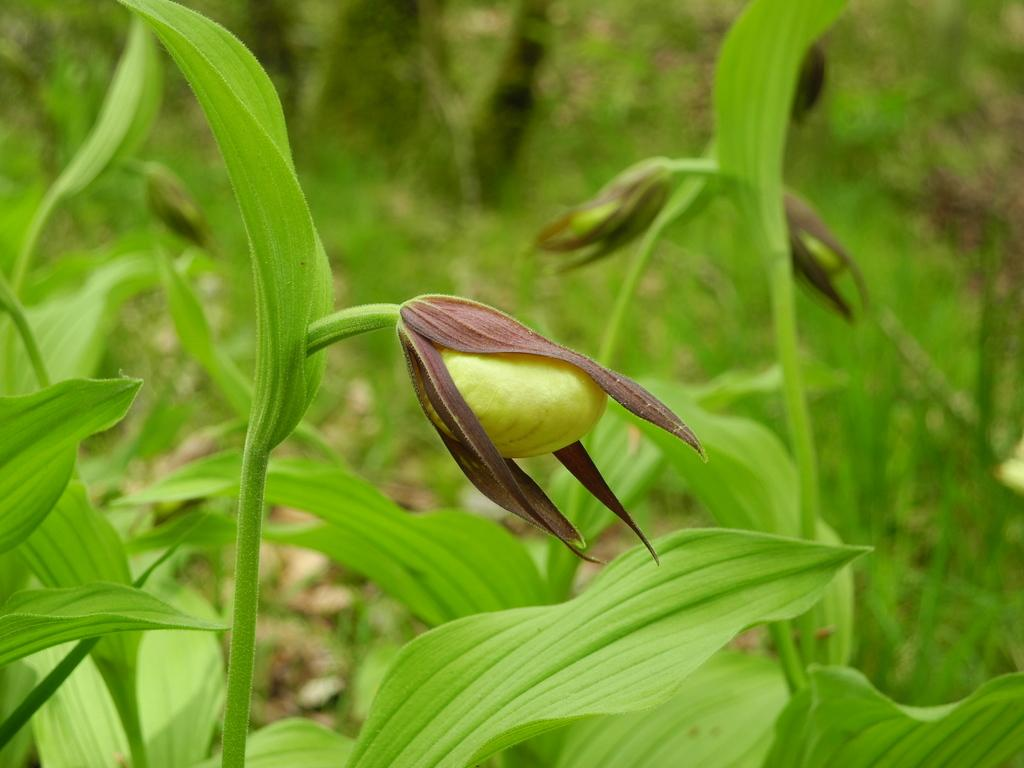What type of living organisms can be seen in the image? Plants can be seen in the image. What stage of growth are the plants in? There are buds visible in the image, which suggests that the plants are in the early stages of growth. What type of powder can be seen covering the plants in the image? There is no powder visible on the plants in the image. What kind of rock formation is present in the image? There is no rock formation present in the image; it features plants with buds. 